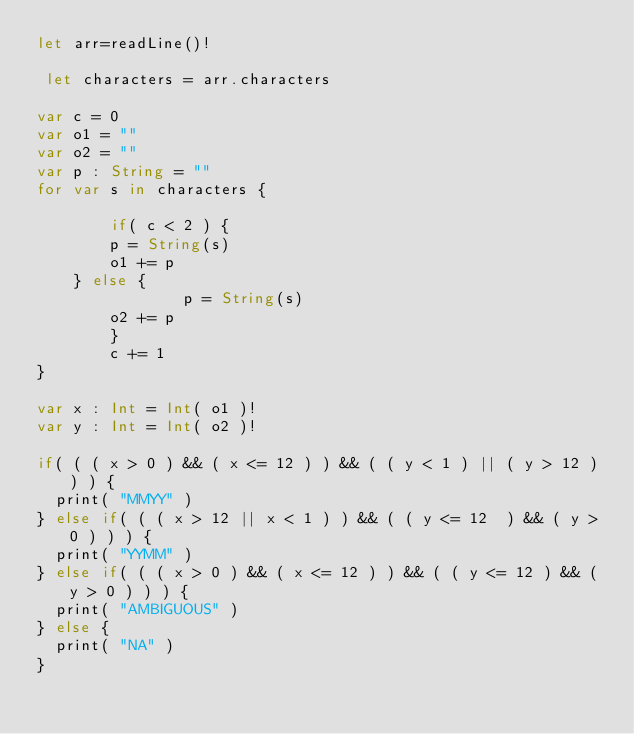Convert code to text. <code><loc_0><loc_0><loc_500><loc_500><_Swift_>let arr=readLine()!

 let characters = arr.characters

var c = 0
var o1 = ""
var o2 = ""
var p : String = ""
for var s in characters {

        if( c < 2 ) {
        p = String(s)
        o1 += p
    } else {
                p = String(s)
        o2 += p
        }
        c += 1
}

var x : Int = Int( o1 )!
var y : Int = Int( o2 )!

if( ( ( x > 0 ) && ( x <= 12 ) ) && ( ( y < 1 ) || ( y > 12 ) ) ) {
  print( "MMYY" )
} else if( ( ( x > 12 || x < 1 ) ) && ( ( y <= 12  ) && ( y > 0 ) ) ) {
  print( "YYMM" )
} else if( ( ( x > 0 ) && ( x <= 12 ) ) && ( ( y <= 12 ) && ( y > 0 ) ) ) {
  print( "AMBIGUOUS" )
} else {
  print( "NA" )
}</code> 